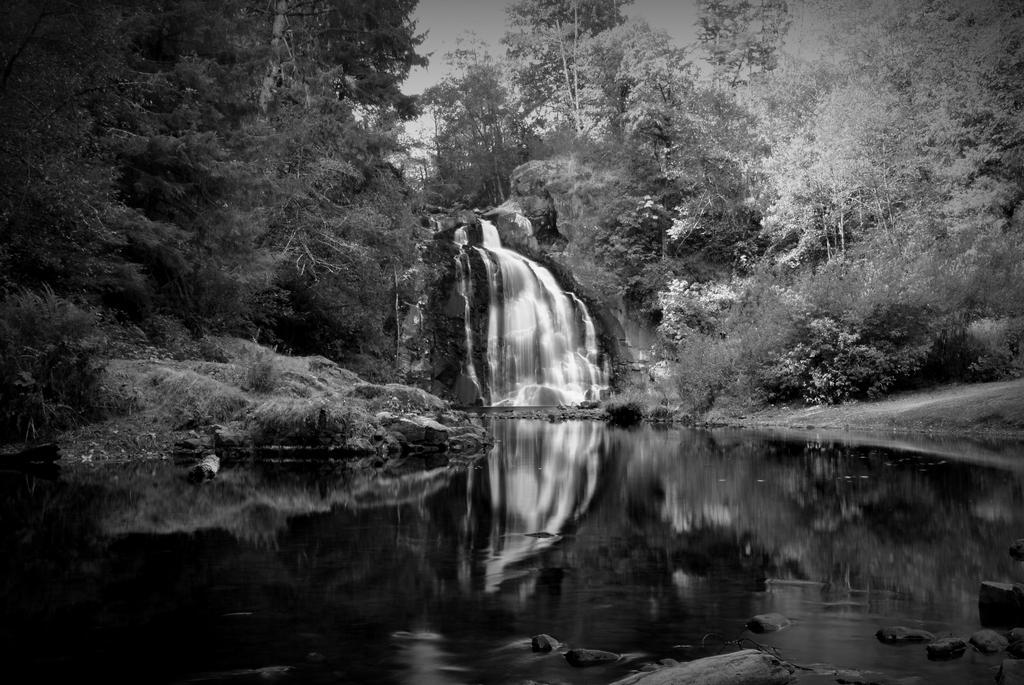In one or two sentences, can you explain what this image depicts? This is a black and white image where we can see there is a waterfall, beside that there are so many trees, in front of that that there is water. 